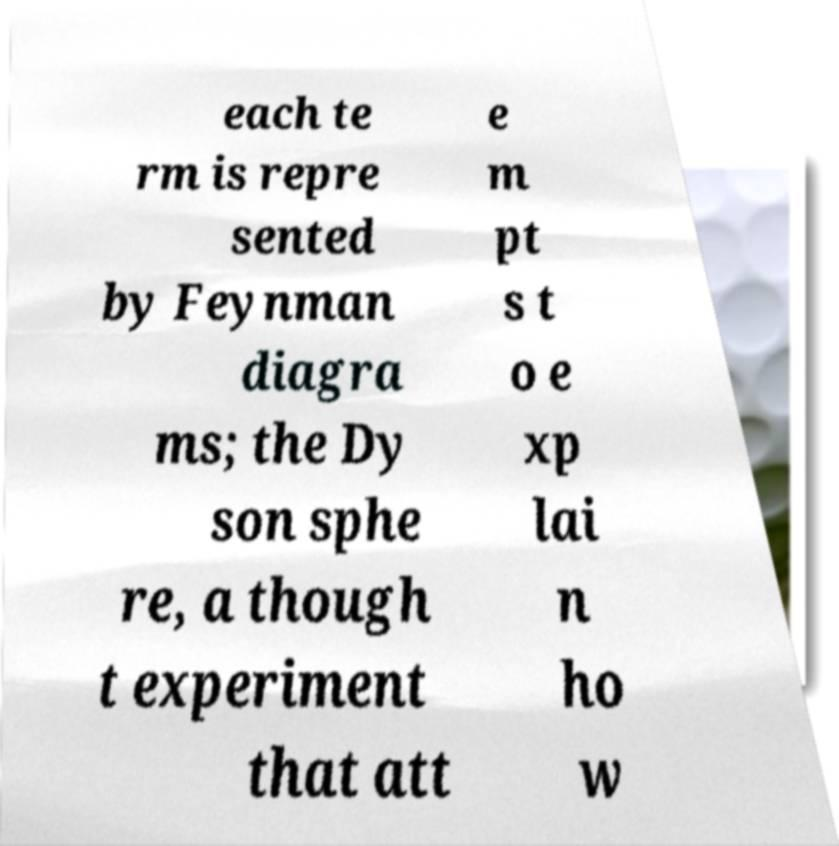Please identify and transcribe the text found in this image. each te rm is repre sented by Feynman diagra ms; the Dy son sphe re, a though t experiment that att e m pt s t o e xp lai n ho w 